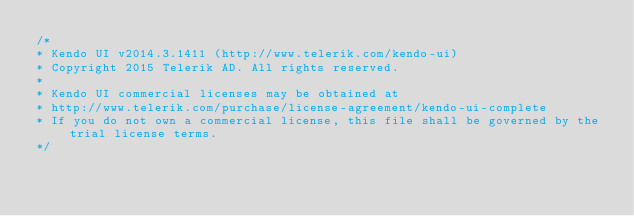Convert code to text. <code><loc_0><loc_0><loc_500><loc_500><_JavaScript_>/*
* Kendo UI v2014.3.1411 (http://www.telerik.com/kendo-ui)
* Copyright 2015 Telerik AD. All rights reserved.
*
* Kendo UI commercial licenses may be obtained at
* http://www.telerik.com/purchase/license-agreement/kendo-ui-complete
* If you do not own a commercial license, this file shall be governed by the trial license terms.
*/</code> 